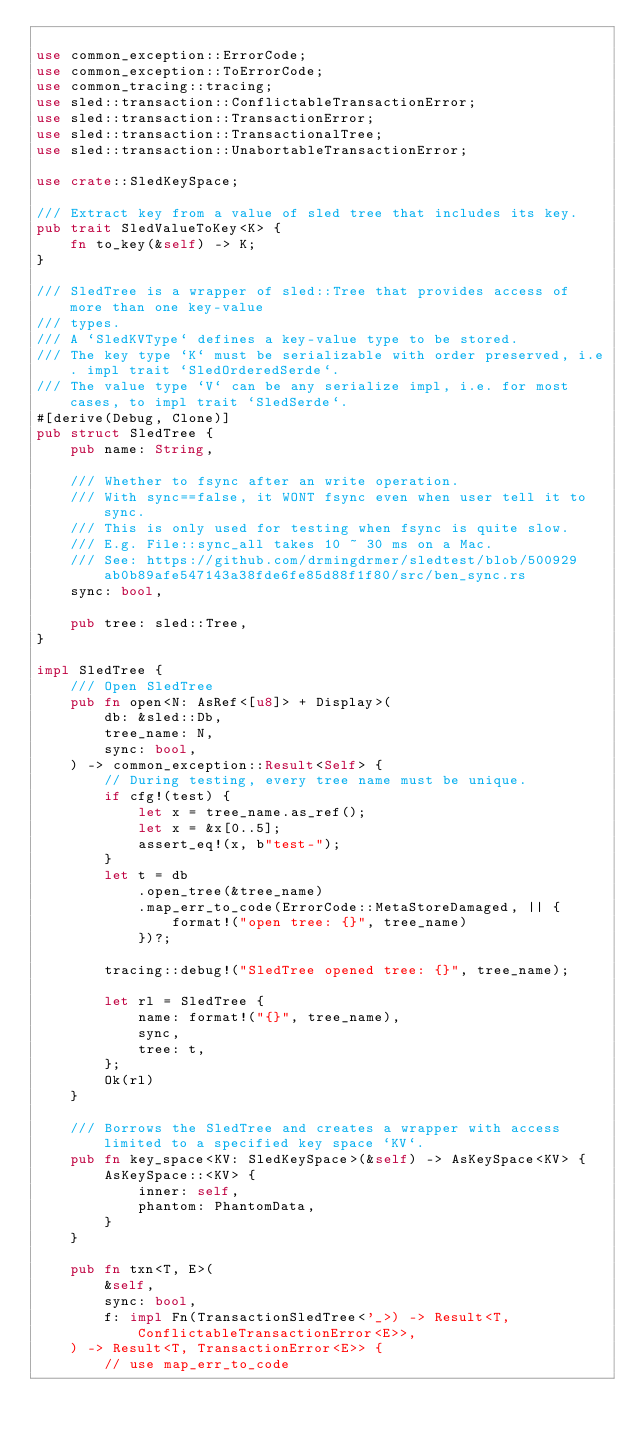<code> <loc_0><loc_0><loc_500><loc_500><_Rust_>
use common_exception::ErrorCode;
use common_exception::ToErrorCode;
use common_tracing::tracing;
use sled::transaction::ConflictableTransactionError;
use sled::transaction::TransactionError;
use sled::transaction::TransactionalTree;
use sled::transaction::UnabortableTransactionError;

use crate::SledKeySpace;

/// Extract key from a value of sled tree that includes its key.
pub trait SledValueToKey<K> {
    fn to_key(&self) -> K;
}

/// SledTree is a wrapper of sled::Tree that provides access of more than one key-value
/// types.
/// A `SledKVType` defines a key-value type to be stored.
/// The key type `K` must be serializable with order preserved, i.e. impl trait `SledOrderedSerde`.
/// The value type `V` can be any serialize impl, i.e. for most cases, to impl trait `SledSerde`.
#[derive(Debug, Clone)]
pub struct SledTree {
    pub name: String,

    /// Whether to fsync after an write operation.
    /// With sync==false, it WONT fsync even when user tell it to sync.
    /// This is only used for testing when fsync is quite slow.
    /// E.g. File::sync_all takes 10 ~ 30 ms on a Mac.
    /// See: https://github.com/drmingdrmer/sledtest/blob/500929ab0b89afe547143a38fde6fe85d88f1f80/src/ben_sync.rs
    sync: bool,

    pub tree: sled::Tree,
}

impl SledTree {
    /// Open SledTree
    pub fn open<N: AsRef<[u8]> + Display>(
        db: &sled::Db,
        tree_name: N,
        sync: bool,
    ) -> common_exception::Result<Self> {
        // During testing, every tree name must be unique.
        if cfg!(test) {
            let x = tree_name.as_ref();
            let x = &x[0..5];
            assert_eq!(x, b"test-");
        }
        let t = db
            .open_tree(&tree_name)
            .map_err_to_code(ErrorCode::MetaStoreDamaged, || {
                format!("open tree: {}", tree_name)
            })?;

        tracing::debug!("SledTree opened tree: {}", tree_name);

        let rl = SledTree {
            name: format!("{}", tree_name),
            sync,
            tree: t,
        };
        Ok(rl)
    }

    /// Borrows the SledTree and creates a wrapper with access limited to a specified key space `KV`.
    pub fn key_space<KV: SledKeySpace>(&self) -> AsKeySpace<KV> {
        AsKeySpace::<KV> {
            inner: self,
            phantom: PhantomData,
        }
    }

    pub fn txn<T, E>(
        &self,
        sync: bool,
        f: impl Fn(TransactionSledTree<'_>) -> Result<T, ConflictableTransactionError<E>>,
    ) -> Result<T, TransactionError<E>> {
        // use map_err_to_code</code> 